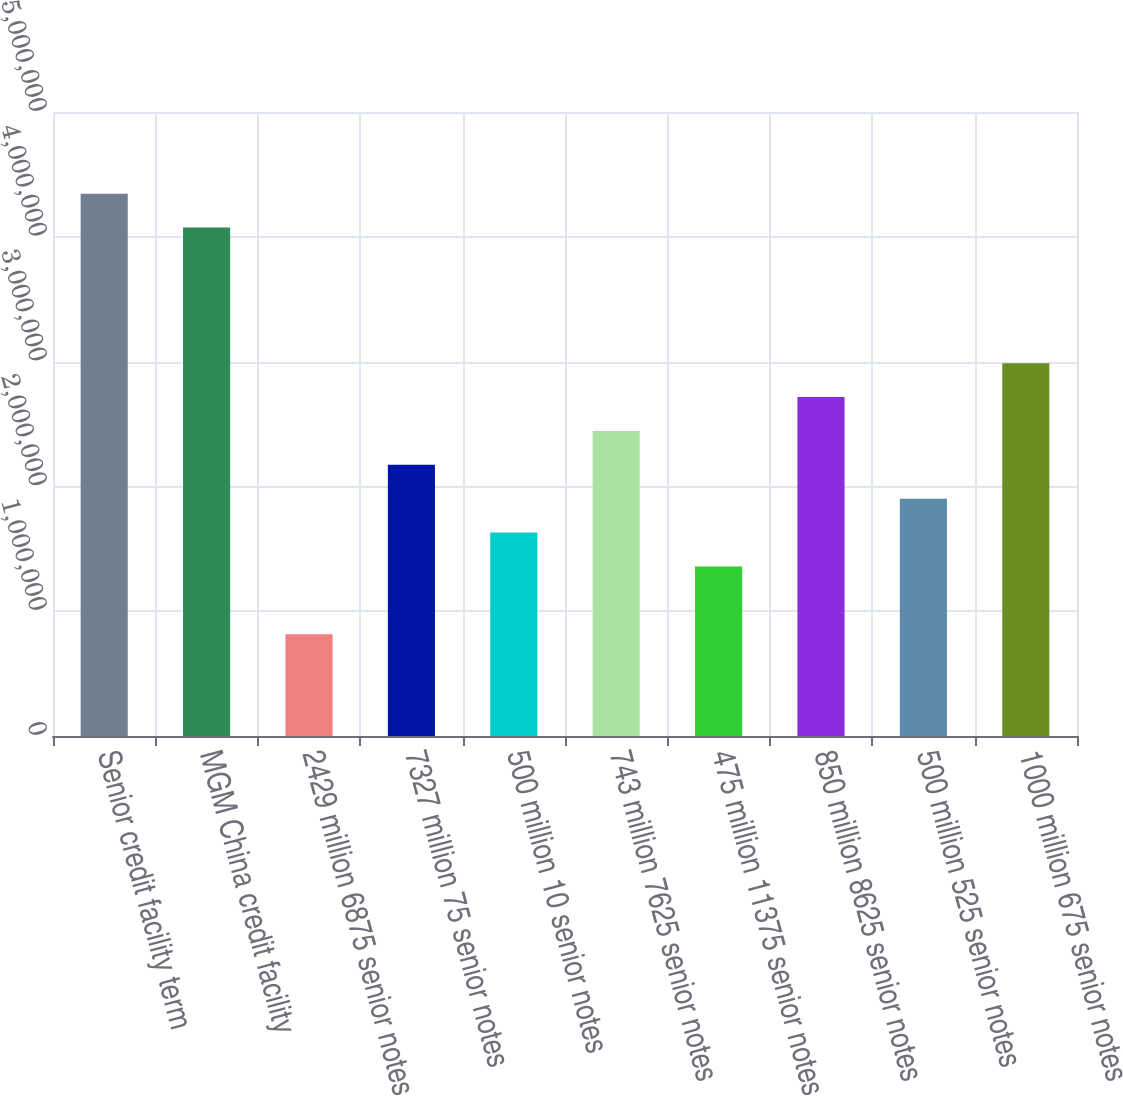<chart> <loc_0><loc_0><loc_500><loc_500><bar_chart><fcel>Senior credit facility term<fcel>MGM China credit facility<fcel>2429 million 6875 senior notes<fcel>7327 million 75 senior notes<fcel>500 million 10 senior notes<fcel>743 million 7625 senior notes<fcel>475 million 11375 senior notes<fcel>850 million 8625 senior notes<fcel>500 million 525 senior notes<fcel>1000 million 675 senior notes<nl><fcel>4.34527e+06<fcel>4.07372e+06<fcel>815186<fcel>2.17291e+06<fcel>1.62982e+06<fcel>2.44446e+06<fcel>1.35828e+06<fcel>2.716e+06<fcel>1.90137e+06<fcel>2.98754e+06<nl></chart> 